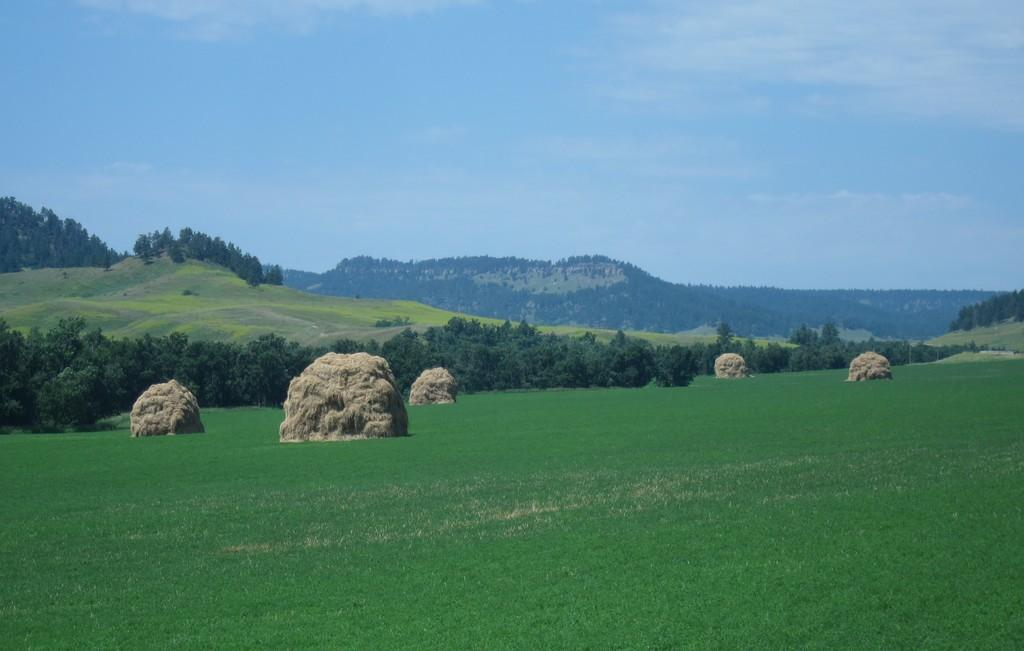What type of vegetation can be seen in the image? There is grass, plants, and trees in the image. What type of natural landform is visible in the image? There are mountains in the image. What part of the natural environment is visible in the image? The sky is visible in the image. Based on the presence of the sky and the absence of stars or a moon, when do you think the image was likely taken? The image was likely taken during the day. How many cats can be seen playing with a toad in the image? There are no cats or toads present in the image. Is there a rifle visible in the image? There is no rifle present in the image. 